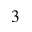<formula> <loc_0><loc_0><loc_500><loc_500>_ { 3 }</formula> 